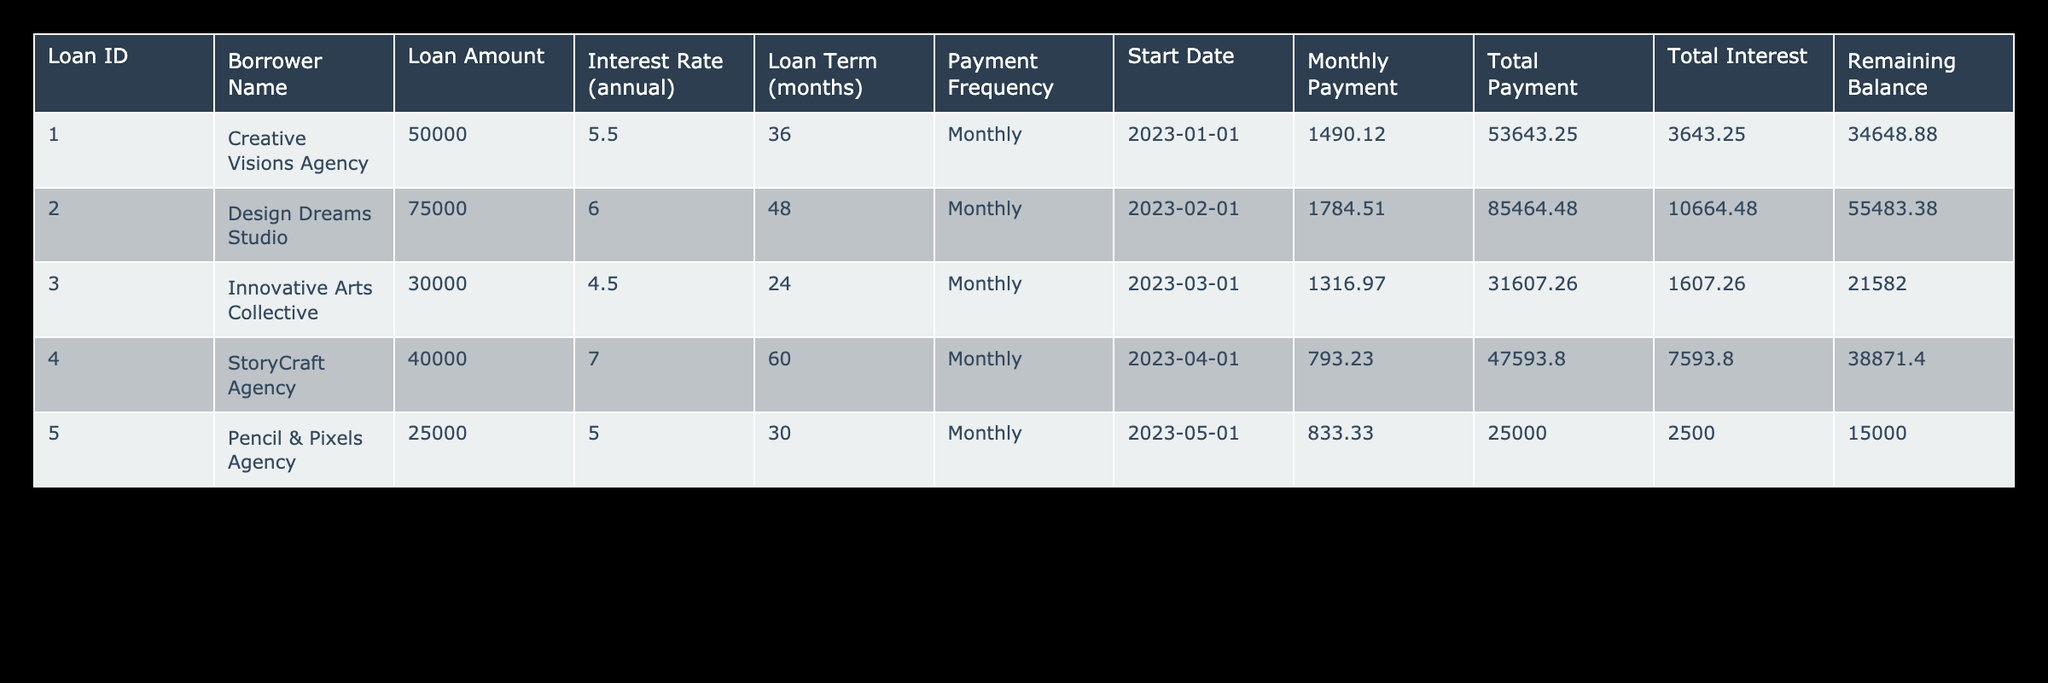What is the loan amount for Creative Visions Agency? The loan amount for Creative Visions Agency is listed directly in the table under the "Loan Amount" column, which shows 50000.
Answer: 50000 What is the total interest paid by Design Dreams Studio? The total interest paid by Design Dreams Studio can be found in the "Total Interest" column, which is 10664.48.
Answer: 10664.48 Which agency has the longest loan term, and what is that duration? By examining the "Loan Term (months)" column, Design Dreams Studio has the longest loan term of 48 months.
Answer: Design Dreams Studio, 48 months What is the average loan amount across all agencies listed? The loan amounts are 50000, 75000, 30000, 40000, and 25000. Adding them gives 200000. Dividing by 5 (the number of loans) gives an average of 40000.
Answer: 40000 Is the interest rate for Pencil & Pixels Agency higher than that for StoryCraft Agency? The interest rate for Pencil & Pixels Agency is 5.0, while for StoryCraft Agency, it is 7.0. Comparing these rates shows that 5.0 is less than 7.0. Therefore, the statement is false.
Answer: No What is the remaining balance for Innovative Arts Collective after the first payment? The remaining balance after the last payment is shown in the "Remaining Balance" column for Innovative Arts Collective, which indicates 21582.00.
Answer: 21582.00 What is the difference in total payments between the smallest and the largest loan amounts? The total payments for Pencil & Pixels Agency is 25000.00, and for Design Dreams Studio, it is 85464.48. The difference is 85464.48 - 25000.00 = 60464.48.
Answer: 60464.48 Which agency pays the least monthly payment, and how much is it? By reviewing the "Monthly Payment" column, Pencil & Pixels Agency has the lowest monthly payment of 833.33.
Answer: Pencil & Pixels Agency, 833.33 Was the interest rate of the loan taken by Creative Visions Agency below average compared to the others? The interest rates for the other loans are 5.5, 6.0, 4.5, 7.0, and 5.0, which average to 5.4. Since 5.5 is not below this average, the answer is false.
Answer: No 